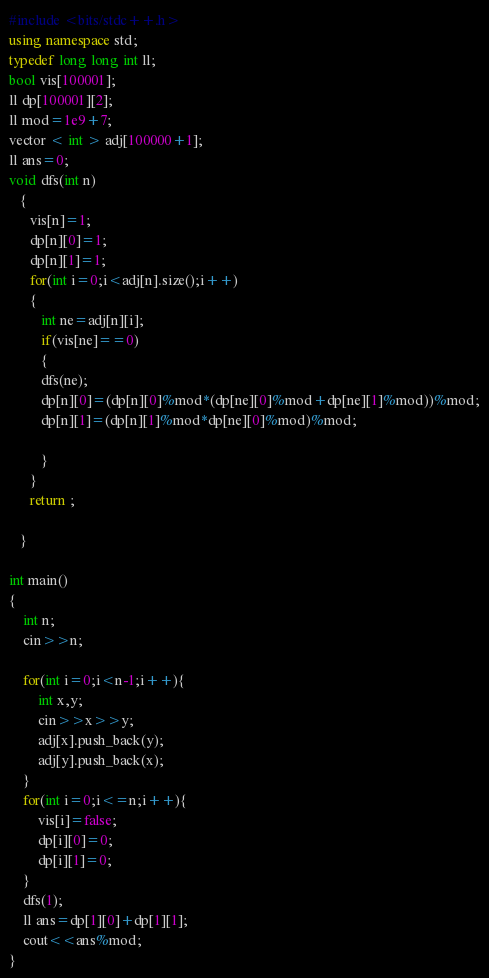Convert code to text. <code><loc_0><loc_0><loc_500><loc_500><_C++_>#include <bits/stdc++.h>
using namespace std;
typedef long long int ll;
bool vis[100001];
ll dp[100001][2];
ll mod=1e9+7;
vector < int > adj[100000+1];
ll ans=0;
void dfs(int n)
   {
      vis[n]=1;
      dp[n][0]=1;
      dp[n][1]=1;
      for(int i=0;i<adj[n].size();i++)
      {
         int ne=adj[n][i];
         if(vis[ne]==0)
         {
         dfs(ne);
         dp[n][0]=(dp[n][0]%mod*(dp[ne][0]%mod+dp[ne][1]%mod))%mod;
         dp[n][1]=(dp[n][1]%mod*dp[ne][0]%mod)%mod;

         }
      }
      return ;

   }

int main()
{
    int n;
    cin>>n;

    for(int i=0;i<n-1;i++){
        int x,y;
        cin>>x>>y;
        adj[x].push_back(y);
        adj[y].push_back(x);
    }
    for(int i=0;i<=n;i++){
        vis[i]=false;
        dp[i][0]=0;
        dp[i][1]=0;
    }
    dfs(1);
    ll ans=dp[1][0]+dp[1][1];
    cout<<ans%mod;
}
</code> 